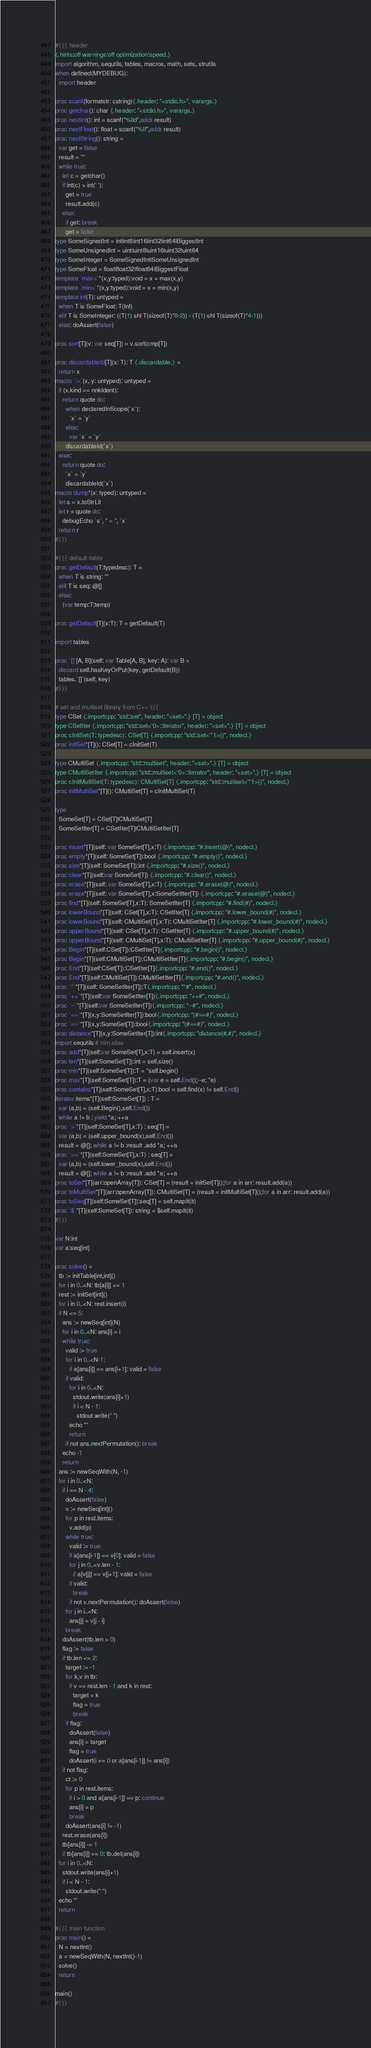<code> <loc_0><loc_0><loc_500><loc_500><_Nim_>#{{{ header
{.hints:off warnings:off optimization:speed.}
import algorithm, sequtils, tables, macros, math, sets, strutils
when defined(MYDEBUG):
  import header

proc scanf(formatstr: cstring){.header: "<stdio.h>", varargs.}
proc getchar(): char {.header: "<stdio.h>", varargs.}
proc nextInt(): int = scanf("%lld",addr result)
proc nextFloat(): float = scanf("%lf",addr result)
proc nextString(): string =
  var get = false
  result = ""
  while true:
    let c = getchar()
    if int(c) > int(' '):
      get = true
      result.add(c)
    else:
      if get: break
      get = false
type SomeSignedInt = int|int8|int16|int32|int64|BiggestInt
type SomeUnsignedInt = uint|uint8|uint16|uint32|uint64
type SomeInteger = SomeSignedInt|SomeUnsignedInt
type SomeFloat = float|float32|float64|BiggestFloat
template `max=`*(x,y:typed):void = x = max(x,y)
template `min=`*(x,y:typed):void = x = min(x,y)
template inf(T): untyped = 
  when T is SomeFloat: T(Inf)
  elif T is SomeInteger: ((T(1) shl T(sizeof(T)*8-2)) - (T(1) shl T(sizeof(T)*4-1)))
  else: doAssert(false)

proc sort[T](v: var seq[T]) = v.sort(cmp[T])

proc discardableId[T](x: T): T {.discardable.} =
  return x
macro `:=`(x, y: untyped): untyped =
  if (x.kind == nnkIdent):
    return quote do:
      when declaredInScope(`x`):
        `x` = `y`
      else:
        var `x` = `y`
      discardableId(`x`)
  else:
    return quote do:
      `x` = `y`
      discardableId(`x`)
macro dump*(x: typed): untyped =
  let s = x.toStrLit
  let r = quote do:
    debugEcho `s`, " = ", `x`
  return r
#}}}

#{{{ default-table
proc getDefault(T:typedesc): T =
  when T is string: ""
  elif T is seq: @[]
  else:
    (var temp:T;temp)

proc getDefault[T](x:T): T = getDefault(T)

import tables

proc `[]`[A, B](self: var Table[A, B], key: A): var B =
  discard self.hasKeyOrPut(key, getDefault(B))
  tables.`[]`(self, key)
#}}}

# set and multiset library from C++ {{{
type CSet {.importcpp: "std::set", header: "<set>".} [T] = object
type CSetIter {.importcpp: "std::set<'0>::iterator", header: "<set>".} [T] = object
proc cInitSet(T: typedesc): CSet[T] {.importcpp: "std::set<'*1>()", nodecl.}
proc initSet*[T](): CSet[T] = cInitSet(T)

type CMultiSet {.importcpp: "std::multiset", header: "<set>".} [T] = object
type CMultiSetIter {.importcpp: "std::multiset<'0>::iterator", header: "<set>".} [T] = object
proc cInitMultiSet(T: typedesc): CMultiSet[T] {.importcpp: "std::multiset<'*1>()", nodecl.}
proc initMultiSet*[T](): CMultiSet[T] = cInitMultiSet(T)

type
  SomeSet[T] = CSet[T]|CMultiSet[T]
  SomeSetIter[T] = CSetIter[T]|CMultiSetIter[T]

proc insert*[T](self: var SomeSet[T],x:T) {.importcpp: "#.insert(@)", nodecl.}
proc empty*[T](self: SomeSet[T]):bool {.importcpp: "#.empty()", nodecl.}
proc size*[T](self: SomeSet[T]):int {.importcpp: "#.size()", nodecl.}
proc clear*[T](self:var SomeSet[T]) {.importcpp: "#.clear()", nodecl.}
proc erase*[T](self: var SomeSet[T],x:T) {.importcpp: "#.erase(@)", nodecl.}
proc erase*[T](self: var SomeSet[T],x:SomeSetIter[T]) {.importcpp: "#.erase(@)", nodecl.}
proc find*[T](self: SomeSet[T],x:T): SomeSetIter[T] {.importcpp: "#.find(#)", nodecl.}
proc lowerBound*[T](self: CSet[T],x:T): CSetIter[T] {.importcpp: "#.lower_bound(#)", nodecl.}
proc lowerBound*[T](self: CMultiSet[T],x:T): CMultiSetIter[T] {.importcpp: "#.lower_bound(#)", nodecl.}
proc upperBound*[T](self: CSet[T],x:T): CSetIter[T] {.importcpp: "#.upper_bound(#)", nodecl.}
proc upperBound*[T](self: CMultiSet[T],x:T): CMultiSetIter[T] {.importcpp: "#.upper_bound(#)", nodecl.}
proc Begin*[T](self:CSet[T]):CSetIter[T]{.importcpp: "#.begin()", nodecl.}
proc Begin*[T](self:CMultiSet[T]):CMultiSetIter[T]{.importcpp: "#.begin()", nodecl.}
proc End*[T](self:CSet[T]):CSetIter[T]{.importcpp: "#.end()", nodecl.}
proc End*[T](self:CMultiSet[T]):CMultiSetIter[T]{.importcpp: "#.end()", nodecl.}
proc `*`*[T](self: SomeSetIter[T]):T{.importcpp: "*#", nodecl.}
proc `++`*[T](self:var SomeSetIter[T]){.importcpp: "++#", nodecl.}
proc `--`*[T](self:var SomeSetIter[T]){.importcpp: "--#", nodecl.}
proc `==`*[T](x,y:SomeSetIter[T]):bool{.importcpp: "(#==#)", nodecl.}
proc `==`*[T](x,y:SomeSet[T]):bool{.importcpp: "(#==#)", nodecl.}
proc distance*[T](x,y:SomeSetIter[T]):int{.importcpp: "distance(#,#)", nodecl.}
import sequtils # nim alias
proc add*[T](self:var SomeSet[T],x:T) = self.insert(x)
proc len*[T](self:SomeSet[T]):int = self.size()
proc min*[T](self:SomeSet[T]):T = *self.begin()
proc max*[T](self:SomeSet[T]):T = (var e = self.End();--e; *e)
proc contains*[T](self:SomeSet[T],x:T):bool = self.find(x) != self.End()
iterator items*[T](self:SomeSet[T]) : T =
  var (a,b) = (self.Begin(),self.End())
  while a != b : yield *a; ++a
proc `>`*[T](self:SomeSet[T],x:T) : seq[T] =
  var (a,b) = (self.upper_bound(x),self.End())
  result = @[]; while a != b :result .add *a; ++a
proc `>=`*[T](self:SomeSet[T],x:T) : seq[T] =
  var (a,b) = (self.lower_bound(x),self.End())
  result = @[]; while a != b :result .add *a; ++a
proc toSet*[T](arr:openArray[T]): CSet[T] = (result = initSet[T]();for a in arr: result.add(a))
proc toMultiSet*[T](arr:openArray[T]): CMultiSet[T] = (result = initMultiSet[T]();for a in arr: result.add(a))
proc toSeq[T](self:SomeSet[T]):seq[T] = self.mapIt(it)
proc `$`*[T](self:SomeSet[T]): string = $self.mapIt(it)
#}}}

var N:int
var a:seq[int]

proc solve() =
  tb := initTable[int,int]()
  for i in 0..<N: tb[a[i]] += 1
  rest := initSet[int]()
  for i in 0..<N: rest.insert(i)
  if N <= 5:
    ans := newSeq[int](N)
    for i in 0..<N: ans[i] = i
    while true:
      valid := true
      for i in 0..<N-1:
        if a[ans[i]] == ans[i+1]: valid = false
      if valid:
        for i in 0..<N:
          stdout.write(ans[i]+1)
          if i < N - 1:
            stdout.write(" ")
        echo ""
        return
      if not ans.nextPermutation(): break
    echo -1
    return
  ans := newSeqWith(N, -1)
  for i in 0..<N:
    if i == N - 4:
      doAssert(false)
      v := newSeq[int]()
      for p in rest.items:
        v.add(p)
      while true:
        valid := true
        if a[ans[i-1]] == v[0]: valid = false
        for j in 0..<v.len - 1:
          if a[v[j]] == v[j+1]: valid = false
        if valid:
          break
        if not v.nextPermutation(): doAssert(false)
      for j in i..<N:
        ans[j] = v[j - i]
      break
    doAssert(tb.len > 0)
    flag := false
    if tb.len <= 2:
      target := -1
      for k,v in tb:
        if v == rest.len - 1 and k in rest:
          target = k
          flag = true
          break
      if flag:
        doAssert(false)
        ans[i] = target
        flag = true
        doAssert(i == 0 or a[ans[i-1]] != ans[i])
    if not flag:
      ct := 0
      for p in rest.items:
        if i > 0 and a[ans[i-1]] == p: continue
        ans[i] = p
        break
      doAssert(ans[i] != -1)
    rest.erase(ans[i])
    tb[ans[i]] -= 1
    if tb[ans[i]] == 0: tb.del(ans[i])
  for i in 0..<N:
    stdout.write(ans[i]+1)
    if i < N - 1:
      stdout.write(" ")
  echo ""
  return

#{{{ main function
proc main() =
  N = nextInt()
  a = newSeqWith(N, nextInt()-1)
  solve()
  return

main()
#}}}</code> 